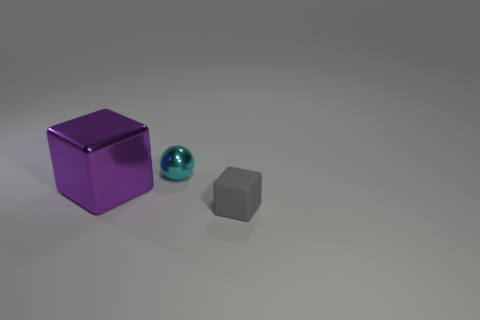Are there more gray objects behind the large purple metal cube than purple cubes?
Provide a short and direct response. No. Do the big metal block and the rubber cube have the same color?
Provide a succinct answer. No. How many matte objects have the same shape as the tiny metallic thing?
Keep it short and to the point. 0. What is the size of the thing that is the same material as the tiny sphere?
Provide a short and direct response. Large. The object that is right of the big block and behind the small cube is what color?
Provide a short and direct response. Cyan. How many cyan rubber cylinders have the same size as the cyan object?
Your response must be concise. 0. What size is the object that is both in front of the tiny cyan metallic object and on the right side of the big metal object?
Keep it short and to the point. Small. How many metal objects are in front of the metal thing to the right of the block that is behind the tiny rubber cube?
Your answer should be very brief. 1. Is there a big metallic ball that has the same color as the large cube?
Give a very brief answer. No. There is a object that is the same size as the ball; what is its color?
Ensure brevity in your answer.  Gray. 